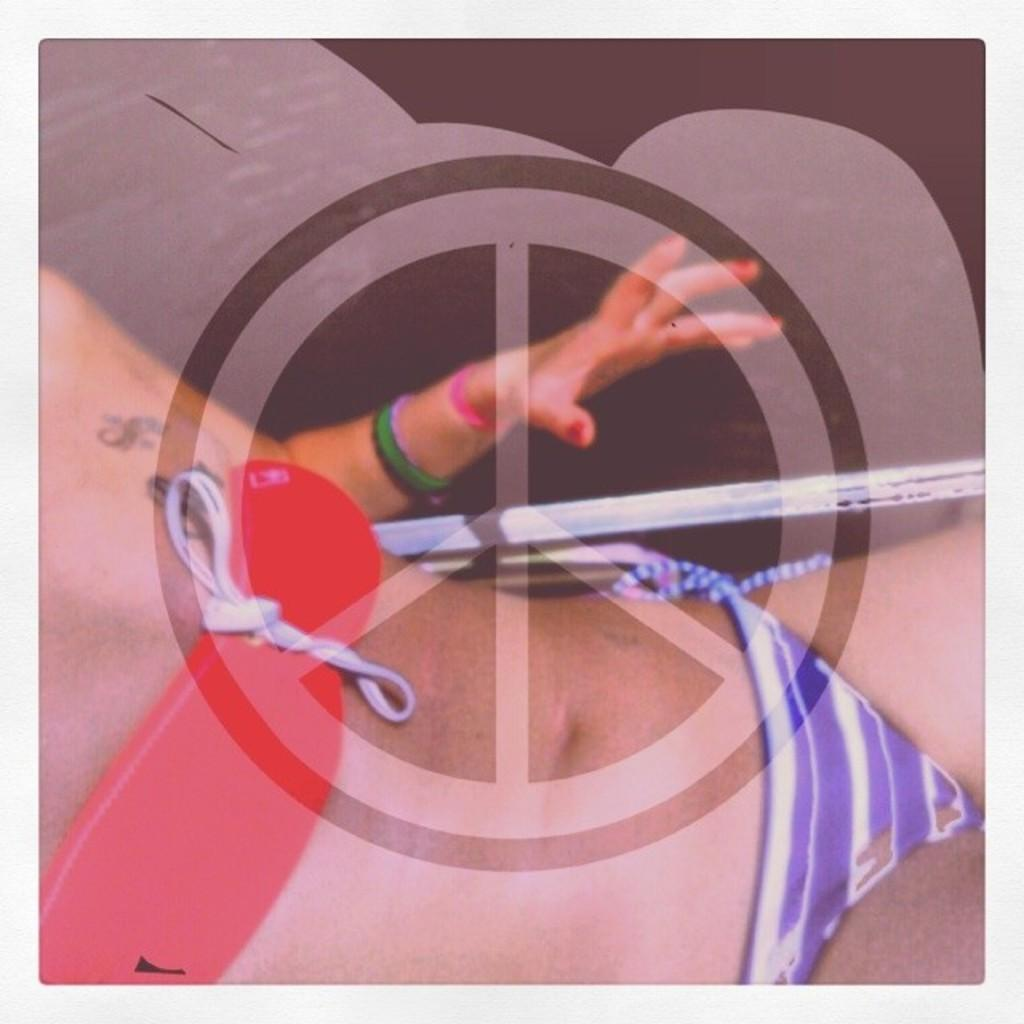What is the main subject of the image? There is a person in the image. Can you describe any other elements in the image? There is a logo in the image. What type of creature can be seen interacting with the logo in the image? There is no creature present in the image; it only features a person and a logo. 